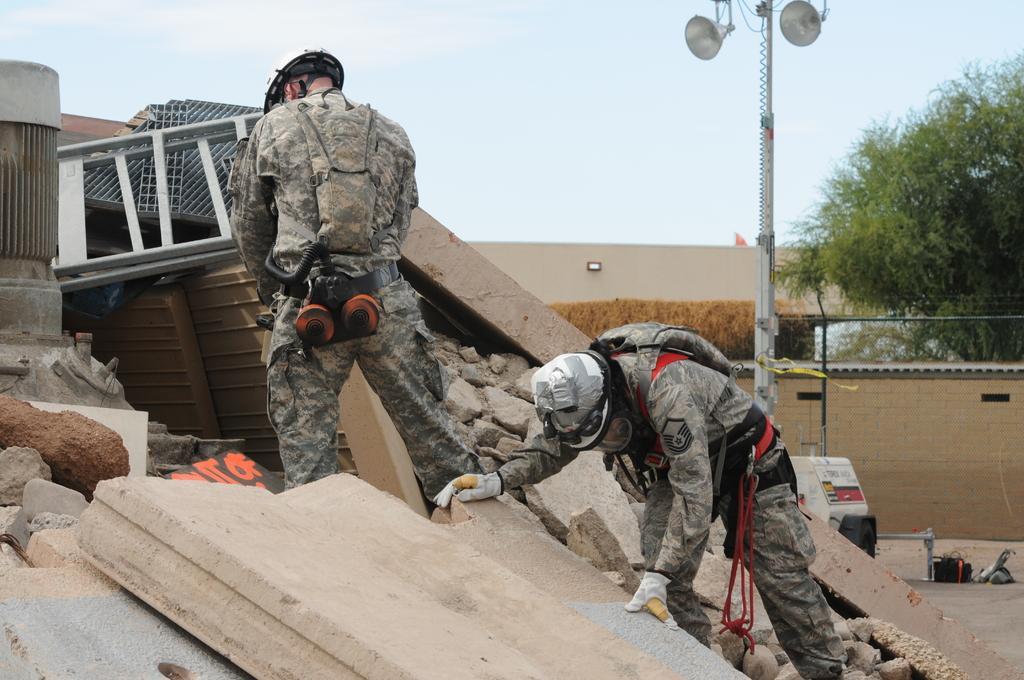Could you give a brief overview of what you see in this image? In this image we can see a person wearing helmet and gloves. There is another person wearing helmet and some other objects. There are stones and slabs. In the back there is a pole with megaphones. On the right side there is a tree. In the background there is sky. Also we can see a wall. 